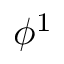Convert formula to latex. <formula><loc_0><loc_0><loc_500><loc_500>\phi ^ { 1 }</formula> 